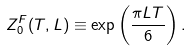Convert formula to latex. <formula><loc_0><loc_0><loc_500><loc_500>Z _ { 0 } ^ { F } ( T , L ) \equiv \exp \left ( \frac { \pi L T } { 6 } \right ) .</formula> 